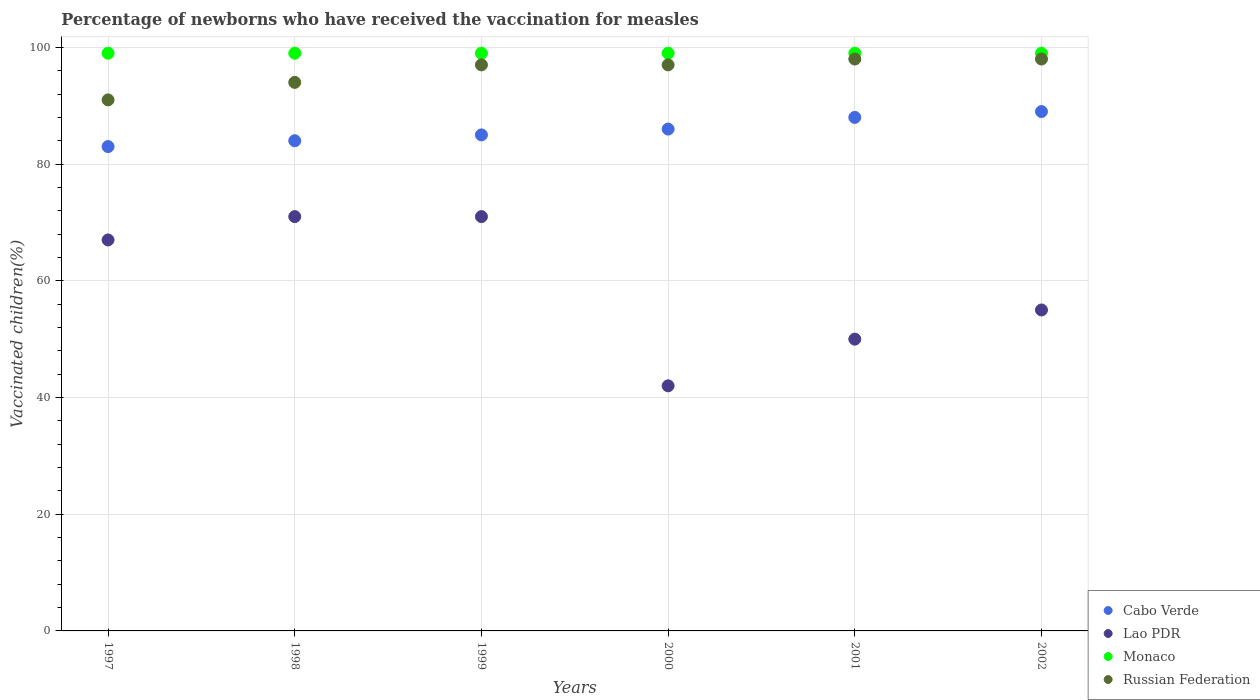Is the number of dotlines equal to the number of legend labels?
Your response must be concise. Yes. Across all years, what is the minimum percentage of vaccinated children in Lao PDR?
Ensure brevity in your answer.  42. In which year was the percentage of vaccinated children in Monaco minimum?
Provide a succinct answer. 1997. What is the total percentage of vaccinated children in Monaco in the graph?
Your answer should be very brief. 594. What is the difference between the percentage of vaccinated children in Cabo Verde in 1998 and that in 2001?
Make the answer very short. -4. What is the average percentage of vaccinated children in Lao PDR per year?
Offer a very short reply. 59.33. In how many years, is the percentage of vaccinated children in Russian Federation greater than the average percentage of vaccinated children in Russian Federation taken over all years?
Your answer should be very brief. 4. Is it the case that in every year, the sum of the percentage of vaccinated children in Monaco and percentage of vaccinated children in Lao PDR  is greater than the percentage of vaccinated children in Cabo Verde?
Offer a terse response. Yes. Does the percentage of vaccinated children in Cabo Verde monotonically increase over the years?
Provide a succinct answer. Yes. How many dotlines are there?
Your response must be concise. 4. What is the difference between two consecutive major ticks on the Y-axis?
Your answer should be very brief. 20. Are the values on the major ticks of Y-axis written in scientific E-notation?
Offer a very short reply. No. Does the graph contain grids?
Offer a very short reply. Yes. Where does the legend appear in the graph?
Offer a very short reply. Bottom right. How many legend labels are there?
Your response must be concise. 4. How are the legend labels stacked?
Your answer should be very brief. Vertical. What is the title of the graph?
Your response must be concise. Percentage of newborns who have received the vaccination for measles. What is the label or title of the Y-axis?
Your answer should be compact. Vaccinated children(%). What is the Vaccinated children(%) of Cabo Verde in 1997?
Give a very brief answer. 83. What is the Vaccinated children(%) in Lao PDR in 1997?
Provide a succinct answer. 67. What is the Vaccinated children(%) in Russian Federation in 1997?
Provide a succinct answer. 91. What is the Vaccinated children(%) in Cabo Verde in 1998?
Provide a succinct answer. 84. What is the Vaccinated children(%) of Lao PDR in 1998?
Your response must be concise. 71. What is the Vaccinated children(%) of Russian Federation in 1998?
Your answer should be compact. 94. What is the Vaccinated children(%) in Cabo Verde in 1999?
Make the answer very short. 85. What is the Vaccinated children(%) of Lao PDR in 1999?
Make the answer very short. 71. What is the Vaccinated children(%) in Russian Federation in 1999?
Offer a terse response. 97. What is the Vaccinated children(%) in Cabo Verde in 2000?
Offer a terse response. 86. What is the Vaccinated children(%) in Monaco in 2000?
Your answer should be very brief. 99. What is the Vaccinated children(%) in Russian Federation in 2000?
Offer a very short reply. 97. What is the Vaccinated children(%) of Cabo Verde in 2001?
Your answer should be compact. 88. What is the Vaccinated children(%) in Russian Federation in 2001?
Your answer should be compact. 98. What is the Vaccinated children(%) in Cabo Verde in 2002?
Provide a short and direct response. 89. What is the Vaccinated children(%) in Lao PDR in 2002?
Keep it short and to the point. 55. What is the Vaccinated children(%) of Monaco in 2002?
Keep it short and to the point. 99. What is the Vaccinated children(%) of Russian Federation in 2002?
Ensure brevity in your answer.  98. Across all years, what is the maximum Vaccinated children(%) of Cabo Verde?
Provide a short and direct response. 89. Across all years, what is the maximum Vaccinated children(%) in Lao PDR?
Offer a terse response. 71. Across all years, what is the maximum Vaccinated children(%) of Monaco?
Your answer should be compact. 99. Across all years, what is the maximum Vaccinated children(%) of Russian Federation?
Provide a short and direct response. 98. Across all years, what is the minimum Vaccinated children(%) in Lao PDR?
Make the answer very short. 42. Across all years, what is the minimum Vaccinated children(%) of Russian Federation?
Your answer should be compact. 91. What is the total Vaccinated children(%) of Cabo Verde in the graph?
Give a very brief answer. 515. What is the total Vaccinated children(%) in Lao PDR in the graph?
Offer a very short reply. 356. What is the total Vaccinated children(%) of Monaco in the graph?
Give a very brief answer. 594. What is the total Vaccinated children(%) of Russian Federation in the graph?
Make the answer very short. 575. What is the difference between the Vaccinated children(%) in Lao PDR in 1997 and that in 1998?
Give a very brief answer. -4. What is the difference between the Vaccinated children(%) of Russian Federation in 1997 and that in 1998?
Offer a very short reply. -3. What is the difference between the Vaccinated children(%) in Cabo Verde in 1997 and that in 1999?
Provide a succinct answer. -2. What is the difference between the Vaccinated children(%) in Lao PDR in 1997 and that in 1999?
Offer a terse response. -4. What is the difference between the Vaccinated children(%) of Russian Federation in 1997 and that in 1999?
Your response must be concise. -6. What is the difference between the Vaccinated children(%) in Lao PDR in 1997 and that in 2001?
Ensure brevity in your answer.  17. What is the difference between the Vaccinated children(%) of Cabo Verde in 1997 and that in 2002?
Your answer should be very brief. -6. What is the difference between the Vaccinated children(%) in Monaco in 1997 and that in 2002?
Offer a very short reply. 0. What is the difference between the Vaccinated children(%) of Monaco in 1998 and that in 1999?
Provide a short and direct response. 0. What is the difference between the Vaccinated children(%) in Russian Federation in 1998 and that in 1999?
Provide a succinct answer. -3. What is the difference between the Vaccinated children(%) of Monaco in 1998 and that in 2000?
Keep it short and to the point. 0. What is the difference between the Vaccinated children(%) in Russian Federation in 1998 and that in 2000?
Offer a very short reply. -3. What is the difference between the Vaccinated children(%) in Cabo Verde in 1998 and that in 2001?
Ensure brevity in your answer.  -4. What is the difference between the Vaccinated children(%) in Monaco in 1998 and that in 2001?
Offer a very short reply. 0. What is the difference between the Vaccinated children(%) in Russian Federation in 1998 and that in 2001?
Offer a terse response. -4. What is the difference between the Vaccinated children(%) of Cabo Verde in 1998 and that in 2002?
Offer a very short reply. -5. What is the difference between the Vaccinated children(%) in Monaco in 1998 and that in 2002?
Provide a succinct answer. 0. What is the difference between the Vaccinated children(%) of Cabo Verde in 1999 and that in 2000?
Provide a short and direct response. -1. What is the difference between the Vaccinated children(%) of Lao PDR in 1999 and that in 2000?
Ensure brevity in your answer.  29. What is the difference between the Vaccinated children(%) of Cabo Verde in 1999 and that in 2001?
Provide a succinct answer. -3. What is the difference between the Vaccinated children(%) in Monaco in 1999 and that in 2002?
Make the answer very short. 0. What is the difference between the Vaccinated children(%) in Russian Federation in 1999 and that in 2002?
Provide a succinct answer. -1. What is the difference between the Vaccinated children(%) in Lao PDR in 2000 and that in 2001?
Keep it short and to the point. -8. What is the difference between the Vaccinated children(%) in Monaco in 2000 and that in 2001?
Offer a very short reply. 0. What is the difference between the Vaccinated children(%) of Russian Federation in 2000 and that in 2001?
Your response must be concise. -1. What is the difference between the Vaccinated children(%) in Cabo Verde in 2000 and that in 2002?
Your answer should be compact. -3. What is the difference between the Vaccinated children(%) of Monaco in 2000 and that in 2002?
Give a very brief answer. 0. What is the difference between the Vaccinated children(%) of Russian Federation in 2000 and that in 2002?
Provide a succinct answer. -1. What is the difference between the Vaccinated children(%) of Cabo Verde in 2001 and that in 2002?
Your response must be concise. -1. What is the difference between the Vaccinated children(%) in Lao PDR in 2001 and that in 2002?
Give a very brief answer. -5. What is the difference between the Vaccinated children(%) of Cabo Verde in 1997 and the Vaccinated children(%) of Lao PDR in 1998?
Offer a very short reply. 12. What is the difference between the Vaccinated children(%) in Cabo Verde in 1997 and the Vaccinated children(%) in Monaco in 1998?
Offer a terse response. -16. What is the difference between the Vaccinated children(%) in Lao PDR in 1997 and the Vaccinated children(%) in Monaco in 1998?
Provide a short and direct response. -32. What is the difference between the Vaccinated children(%) of Lao PDR in 1997 and the Vaccinated children(%) of Russian Federation in 1998?
Provide a succinct answer. -27. What is the difference between the Vaccinated children(%) of Cabo Verde in 1997 and the Vaccinated children(%) of Lao PDR in 1999?
Keep it short and to the point. 12. What is the difference between the Vaccinated children(%) in Lao PDR in 1997 and the Vaccinated children(%) in Monaco in 1999?
Ensure brevity in your answer.  -32. What is the difference between the Vaccinated children(%) in Cabo Verde in 1997 and the Vaccinated children(%) in Lao PDR in 2000?
Give a very brief answer. 41. What is the difference between the Vaccinated children(%) of Cabo Verde in 1997 and the Vaccinated children(%) of Monaco in 2000?
Give a very brief answer. -16. What is the difference between the Vaccinated children(%) in Cabo Verde in 1997 and the Vaccinated children(%) in Russian Federation in 2000?
Your response must be concise. -14. What is the difference between the Vaccinated children(%) in Lao PDR in 1997 and the Vaccinated children(%) in Monaco in 2000?
Your response must be concise. -32. What is the difference between the Vaccinated children(%) in Lao PDR in 1997 and the Vaccinated children(%) in Russian Federation in 2000?
Offer a very short reply. -30. What is the difference between the Vaccinated children(%) in Cabo Verde in 1997 and the Vaccinated children(%) in Russian Federation in 2001?
Ensure brevity in your answer.  -15. What is the difference between the Vaccinated children(%) in Lao PDR in 1997 and the Vaccinated children(%) in Monaco in 2001?
Provide a short and direct response. -32. What is the difference between the Vaccinated children(%) in Lao PDR in 1997 and the Vaccinated children(%) in Russian Federation in 2001?
Your answer should be compact. -31. What is the difference between the Vaccinated children(%) in Lao PDR in 1997 and the Vaccinated children(%) in Monaco in 2002?
Provide a short and direct response. -32. What is the difference between the Vaccinated children(%) of Lao PDR in 1997 and the Vaccinated children(%) of Russian Federation in 2002?
Provide a succinct answer. -31. What is the difference between the Vaccinated children(%) in Monaco in 1997 and the Vaccinated children(%) in Russian Federation in 2002?
Keep it short and to the point. 1. What is the difference between the Vaccinated children(%) of Cabo Verde in 1998 and the Vaccinated children(%) of Lao PDR in 2000?
Provide a succinct answer. 42. What is the difference between the Vaccinated children(%) in Cabo Verde in 1998 and the Vaccinated children(%) in Russian Federation in 2000?
Provide a short and direct response. -13. What is the difference between the Vaccinated children(%) of Lao PDR in 1998 and the Vaccinated children(%) of Russian Federation in 2000?
Offer a terse response. -26. What is the difference between the Vaccinated children(%) of Monaco in 1998 and the Vaccinated children(%) of Russian Federation in 2000?
Your answer should be compact. 2. What is the difference between the Vaccinated children(%) in Cabo Verde in 1998 and the Vaccinated children(%) in Monaco in 2001?
Offer a very short reply. -15. What is the difference between the Vaccinated children(%) in Cabo Verde in 1998 and the Vaccinated children(%) in Russian Federation in 2001?
Ensure brevity in your answer.  -14. What is the difference between the Vaccinated children(%) in Lao PDR in 1998 and the Vaccinated children(%) in Russian Federation in 2001?
Offer a terse response. -27. What is the difference between the Vaccinated children(%) of Cabo Verde in 1998 and the Vaccinated children(%) of Monaco in 2002?
Make the answer very short. -15. What is the difference between the Vaccinated children(%) of Cabo Verde in 1998 and the Vaccinated children(%) of Russian Federation in 2002?
Your response must be concise. -14. What is the difference between the Vaccinated children(%) in Lao PDR in 1998 and the Vaccinated children(%) in Monaco in 2002?
Your answer should be compact. -28. What is the difference between the Vaccinated children(%) in Cabo Verde in 1999 and the Vaccinated children(%) in Lao PDR in 2000?
Your answer should be very brief. 43. What is the difference between the Vaccinated children(%) in Cabo Verde in 1999 and the Vaccinated children(%) in Russian Federation in 2000?
Ensure brevity in your answer.  -12. What is the difference between the Vaccinated children(%) of Monaco in 1999 and the Vaccinated children(%) of Russian Federation in 2000?
Offer a very short reply. 2. What is the difference between the Vaccinated children(%) in Cabo Verde in 1999 and the Vaccinated children(%) in Lao PDR in 2001?
Your answer should be very brief. 35. What is the difference between the Vaccinated children(%) of Cabo Verde in 1999 and the Vaccinated children(%) of Monaco in 2001?
Your response must be concise. -14. What is the difference between the Vaccinated children(%) in Lao PDR in 1999 and the Vaccinated children(%) in Russian Federation in 2001?
Offer a very short reply. -27. What is the difference between the Vaccinated children(%) in Cabo Verde in 1999 and the Vaccinated children(%) in Lao PDR in 2002?
Offer a very short reply. 30. What is the difference between the Vaccinated children(%) of Lao PDR in 1999 and the Vaccinated children(%) of Monaco in 2002?
Give a very brief answer. -28. What is the difference between the Vaccinated children(%) in Monaco in 1999 and the Vaccinated children(%) in Russian Federation in 2002?
Offer a very short reply. 1. What is the difference between the Vaccinated children(%) in Cabo Verde in 2000 and the Vaccinated children(%) in Monaco in 2001?
Provide a short and direct response. -13. What is the difference between the Vaccinated children(%) in Cabo Verde in 2000 and the Vaccinated children(%) in Russian Federation in 2001?
Keep it short and to the point. -12. What is the difference between the Vaccinated children(%) in Lao PDR in 2000 and the Vaccinated children(%) in Monaco in 2001?
Your answer should be compact. -57. What is the difference between the Vaccinated children(%) in Lao PDR in 2000 and the Vaccinated children(%) in Russian Federation in 2001?
Ensure brevity in your answer.  -56. What is the difference between the Vaccinated children(%) in Lao PDR in 2000 and the Vaccinated children(%) in Monaco in 2002?
Your answer should be very brief. -57. What is the difference between the Vaccinated children(%) of Lao PDR in 2000 and the Vaccinated children(%) of Russian Federation in 2002?
Make the answer very short. -56. What is the difference between the Vaccinated children(%) in Cabo Verde in 2001 and the Vaccinated children(%) in Monaco in 2002?
Keep it short and to the point. -11. What is the difference between the Vaccinated children(%) in Cabo Verde in 2001 and the Vaccinated children(%) in Russian Federation in 2002?
Offer a terse response. -10. What is the difference between the Vaccinated children(%) of Lao PDR in 2001 and the Vaccinated children(%) of Monaco in 2002?
Provide a short and direct response. -49. What is the difference between the Vaccinated children(%) of Lao PDR in 2001 and the Vaccinated children(%) of Russian Federation in 2002?
Offer a very short reply. -48. What is the difference between the Vaccinated children(%) in Monaco in 2001 and the Vaccinated children(%) in Russian Federation in 2002?
Provide a short and direct response. 1. What is the average Vaccinated children(%) in Cabo Verde per year?
Give a very brief answer. 85.83. What is the average Vaccinated children(%) in Lao PDR per year?
Provide a succinct answer. 59.33. What is the average Vaccinated children(%) in Monaco per year?
Offer a very short reply. 99. What is the average Vaccinated children(%) in Russian Federation per year?
Offer a terse response. 95.83. In the year 1997, what is the difference between the Vaccinated children(%) in Cabo Verde and Vaccinated children(%) in Lao PDR?
Offer a terse response. 16. In the year 1997, what is the difference between the Vaccinated children(%) in Cabo Verde and Vaccinated children(%) in Monaco?
Your answer should be compact. -16. In the year 1997, what is the difference between the Vaccinated children(%) in Cabo Verde and Vaccinated children(%) in Russian Federation?
Your answer should be compact. -8. In the year 1997, what is the difference between the Vaccinated children(%) in Lao PDR and Vaccinated children(%) in Monaco?
Make the answer very short. -32. In the year 1998, what is the difference between the Vaccinated children(%) in Cabo Verde and Vaccinated children(%) in Russian Federation?
Your answer should be very brief. -10. In the year 1999, what is the difference between the Vaccinated children(%) of Cabo Verde and Vaccinated children(%) of Lao PDR?
Give a very brief answer. 14. In the year 1999, what is the difference between the Vaccinated children(%) in Cabo Verde and Vaccinated children(%) in Monaco?
Your answer should be very brief. -14. In the year 1999, what is the difference between the Vaccinated children(%) in Lao PDR and Vaccinated children(%) in Russian Federation?
Offer a very short reply. -26. In the year 2000, what is the difference between the Vaccinated children(%) of Lao PDR and Vaccinated children(%) of Monaco?
Provide a short and direct response. -57. In the year 2000, what is the difference between the Vaccinated children(%) in Lao PDR and Vaccinated children(%) in Russian Federation?
Make the answer very short. -55. In the year 2001, what is the difference between the Vaccinated children(%) in Cabo Verde and Vaccinated children(%) in Lao PDR?
Your response must be concise. 38. In the year 2001, what is the difference between the Vaccinated children(%) in Cabo Verde and Vaccinated children(%) in Monaco?
Provide a succinct answer. -11. In the year 2001, what is the difference between the Vaccinated children(%) in Cabo Verde and Vaccinated children(%) in Russian Federation?
Provide a short and direct response. -10. In the year 2001, what is the difference between the Vaccinated children(%) in Lao PDR and Vaccinated children(%) in Monaco?
Your answer should be compact. -49. In the year 2001, what is the difference between the Vaccinated children(%) in Lao PDR and Vaccinated children(%) in Russian Federation?
Make the answer very short. -48. In the year 2002, what is the difference between the Vaccinated children(%) of Lao PDR and Vaccinated children(%) of Monaco?
Your answer should be compact. -44. In the year 2002, what is the difference between the Vaccinated children(%) of Lao PDR and Vaccinated children(%) of Russian Federation?
Give a very brief answer. -43. What is the ratio of the Vaccinated children(%) of Cabo Verde in 1997 to that in 1998?
Ensure brevity in your answer.  0.99. What is the ratio of the Vaccinated children(%) in Lao PDR in 1997 to that in 1998?
Provide a short and direct response. 0.94. What is the ratio of the Vaccinated children(%) in Russian Federation in 1997 to that in 1998?
Your response must be concise. 0.97. What is the ratio of the Vaccinated children(%) in Cabo Verde in 1997 to that in 1999?
Provide a succinct answer. 0.98. What is the ratio of the Vaccinated children(%) of Lao PDR in 1997 to that in 1999?
Provide a short and direct response. 0.94. What is the ratio of the Vaccinated children(%) of Monaco in 1997 to that in 1999?
Offer a terse response. 1. What is the ratio of the Vaccinated children(%) in Russian Federation in 1997 to that in 1999?
Ensure brevity in your answer.  0.94. What is the ratio of the Vaccinated children(%) in Cabo Verde in 1997 to that in 2000?
Your response must be concise. 0.97. What is the ratio of the Vaccinated children(%) of Lao PDR in 1997 to that in 2000?
Offer a very short reply. 1.6. What is the ratio of the Vaccinated children(%) of Russian Federation in 1997 to that in 2000?
Provide a succinct answer. 0.94. What is the ratio of the Vaccinated children(%) in Cabo Verde in 1997 to that in 2001?
Provide a short and direct response. 0.94. What is the ratio of the Vaccinated children(%) of Lao PDR in 1997 to that in 2001?
Your answer should be very brief. 1.34. What is the ratio of the Vaccinated children(%) of Monaco in 1997 to that in 2001?
Ensure brevity in your answer.  1. What is the ratio of the Vaccinated children(%) in Russian Federation in 1997 to that in 2001?
Provide a short and direct response. 0.93. What is the ratio of the Vaccinated children(%) of Cabo Verde in 1997 to that in 2002?
Your answer should be very brief. 0.93. What is the ratio of the Vaccinated children(%) of Lao PDR in 1997 to that in 2002?
Ensure brevity in your answer.  1.22. What is the ratio of the Vaccinated children(%) of Monaco in 1997 to that in 2002?
Provide a short and direct response. 1. What is the ratio of the Vaccinated children(%) of Cabo Verde in 1998 to that in 1999?
Keep it short and to the point. 0.99. What is the ratio of the Vaccinated children(%) in Russian Federation in 1998 to that in 1999?
Provide a succinct answer. 0.97. What is the ratio of the Vaccinated children(%) of Cabo Verde in 1998 to that in 2000?
Offer a terse response. 0.98. What is the ratio of the Vaccinated children(%) in Lao PDR in 1998 to that in 2000?
Make the answer very short. 1.69. What is the ratio of the Vaccinated children(%) of Monaco in 1998 to that in 2000?
Offer a very short reply. 1. What is the ratio of the Vaccinated children(%) of Russian Federation in 1998 to that in 2000?
Offer a terse response. 0.97. What is the ratio of the Vaccinated children(%) in Cabo Verde in 1998 to that in 2001?
Your answer should be very brief. 0.95. What is the ratio of the Vaccinated children(%) of Lao PDR in 1998 to that in 2001?
Your answer should be very brief. 1.42. What is the ratio of the Vaccinated children(%) of Russian Federation in 1998 to that in 2001?
Ensure brevity in your answer.  0.96. What is the ratio of the Vaccinated children(%) in Cabo Verde in 1998 to that in 2002?
Keep it short and to the point. 0.94. What is the ratio of the Vaccinated children(%) of Lao PDR in 1998 to that in 2002?
Offer a very short reply. 1.29. What is the ratio of the Vaccinated children(%) in Monaco in 1998 to that in 2002?
Your response must be concise. 1. What is the ratio of the Vaccinated children(%) of Russian Federation in 1998 to that in 2002?
Offer a very short reply. 0.96. What is the ratio of the Vaccinated children(%) of Cabo Verde in 1999 to that in 2000?
Provide a succinct answer. 0.99. What is the ratio of the Vaccinated children(%) in Lao PDR in 1999 to that in 2000?
Make the answer very short. 1.69. What is the ratio of the Vaccinated children(%) in Monaco in 1999 to that in 2000?
Provide a succinct answer. 1. What is the ratio of the Vaccinated children(%) of Cabo Verde in 1999 to that in 2001?
Make the answer very short. 0.97. What is the ratio of the Vaccinated children(%) of Lao PDR in 1999 to that in 2001?
Offer a terse response. 1.42. What is the ratio of the Vaccinated children(%) of Monaco in 1999 to that in 2001?
Provide a short and direct response. 1. What is the ratio of the Vaccinated children(%) in Cabo Verde in 1999 to that in 2002?
Provide a succinct answer. 0.96. What is the ratio of the Vaccinated children(%) of Lao PDR in 1999 to that in 2002?
Provide a succinct answer. 1.29. What is the ratio of the Vaccinated children(%) in Russian Federation in 1999 to that in 2002?
Make the answer very short. 0.99. What is the ratio of the Vaccinated children(%) of Cabo Verde in 2000 to that in 2001?
Provide a succinct answer. 0.98. What is the ratio of the Vaccinated children(%) in Lao PDR in 2000 to that in 2001?
Your answer should be compact. 0.84. What is the ratio of the Vaccinated children(%) of Monaco in 2000 to that in 2001?
Ensure brevity in your answer.  1. What is the ratio of the Vaccinated children(%) in Cabo Verde in 2000 to that in 2002?
Provide a short and direct response. 0.97. What is the ratio of the Vaccinated children(%) in Lao PDR in 2000 to that in 2002?
Make the answer very short. 0.76. What is the ratio of the Vaccinated children(%) in Monaco in 2000 to that in 2002?
Your answer should be compact. 1. What is the ratio of the Vaccinated children(%) of Cabo Verde in 2001 to that in 2002?
Your answer should be compact. 0.99. What is the ratio of the Vaccinated children(%) of Monaco in 2001 to that in 2002?
Your response must be concise. 1. What is the difference between the highest and the second highest Vaccinated children(%) in Cabo Verde?
Provide a short and direct response. 1. What is the difference between the highest and the second highest Vaccinated children(%) in Monaco?
Your answer should be very brief. 0. What is the difference between the highest and the lowest Vaccinated children(%) in Cabo Verde?
Make the answer very short. 6. What is the difference between the highest and the lowest Vaccinated children(%) in Lao PDR?
Ensure brevity in your answer.  29. What is the difference between the highest and the lowest Vaccinated children(%) in Monaco?
Provide a succinct answer. 0. 